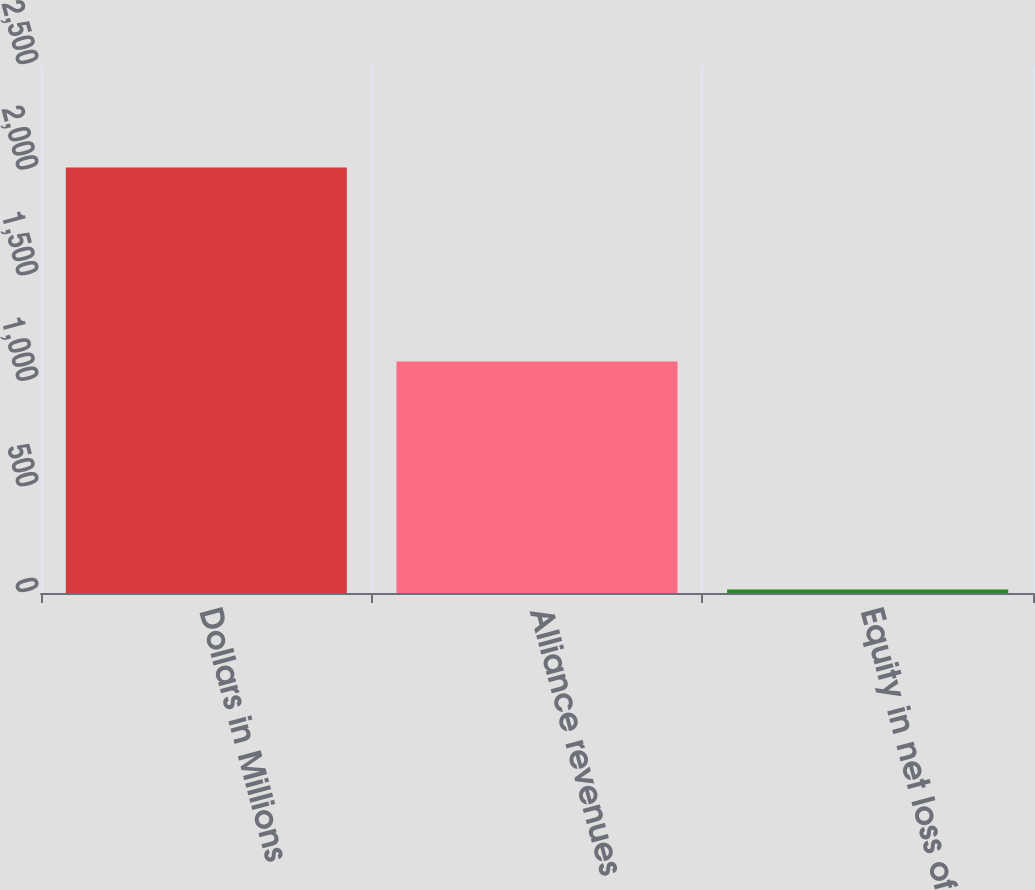Convert chart to OTSL. <chart><loc_0><loc_0><loc_500><loc_500><bar_chart><fcel>Dollars in Millions<fcel>Alliance revenues<fcel>Equity in net loss of<nl><fcel>2015<fcel>1096<fcel>17<nl></chart> 